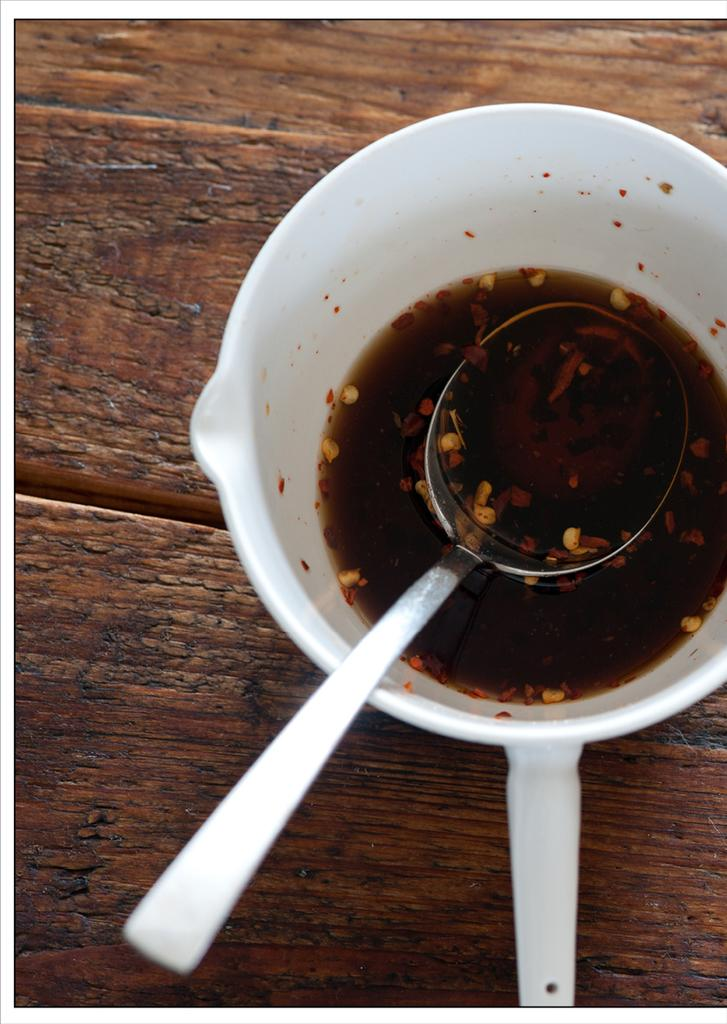What object is inside the cup in the image? There is a spoon in a cup in the image. What can be seen in the background of the image? There is a wooden board visible in the background of the image. How does the wrench help in the process of making the cup in the image? There is no wrench present in the image, and the image does not depict the process of making a cup. 